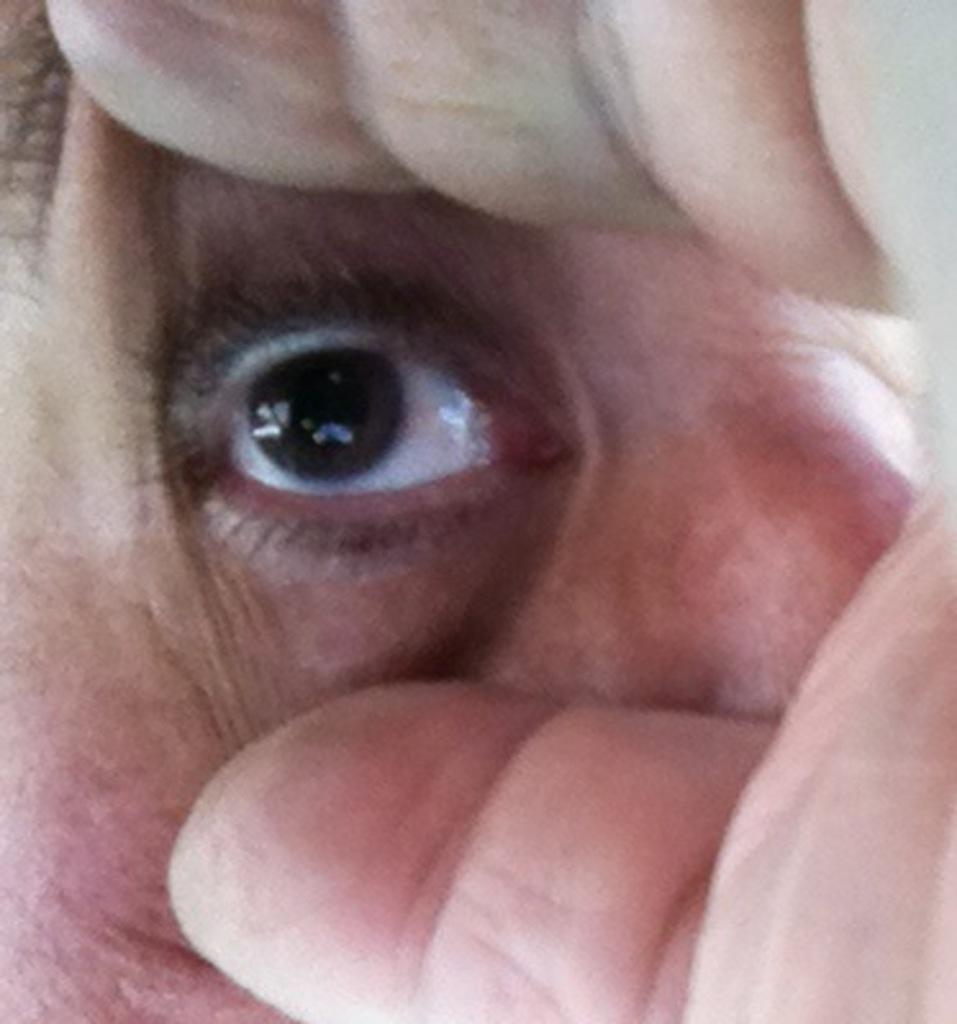Could you give a brief overview of what you see in this image? In this image we can a person hand and he is trying to to open his eye with the help of his hand. 